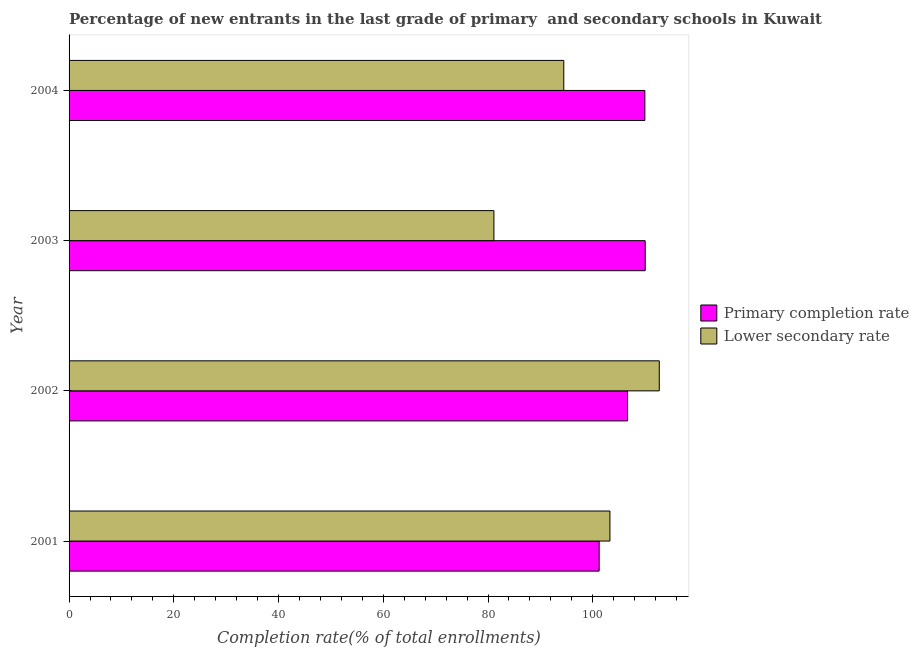How many different coloured bars are there?
Your answer should be very brief. 2. How many groups of bars are there?
Make the answer very short. 4. Are the number of bars on each tick of the Y-axis equal?
Your answer should be compact. Yes. How many bars are there on the 4th tick from the top?
Provide a short and direct response. 2. How many bars are there on the 4th tick from the bottom?
Provide a succinct answer. 2. What is the label of the 3rd group of bars from the top?
Ensure brevity in your answer.  2002. In how many cases, is the number of bars for a given year not equal to the number of legend labels?
Provide a succinct answer. 0. What is the completion rate in secondary schools in 2003?
Keep it short and to the point. 81.13. Across all years, what is the maximum completion rate in primary schools?
Make the answer very short. 110.02. Across all years, what is the minimum completion rate in primary schools?
Keep it short and to the point. 101.23. In which year was the completion rate in primary schools maximum?
Offer a very short reply. 2003. In which year was the completion rate in primary schools minimum?
Your response must be concise. 2001. What is the total completion rate in secondary schools in the graph?
Your answer should be very brief. 391.6. What is the difference between the completion rate in primary schools in 2003 and that in 2004?
Your answer should be compact. 0.06. What is the difference between the completion rate in primary schools in 2004 and the completion rate in secondary schools in 2001?
Provide a short and direct response. 6.67. What is the average completion rate in primary schools per year?
Your answer should be very brief. 106.96. In the year 2004, what is the difference between the completion rate in secondary schools and completion rate in primary schools?
Ensure brevity in your answer.  -15.48. What is the ratio of the completion rate in primary schools in 2001 to that in 2002?
Your response must be concise. 0.95. Is the completion rate in primary schools in 2001 less than that in 2003?
Offer a terse response. Yes. Is the difference between the completion rate in secondary schools in 2002 and 2003 greater than the difference between the completion rate in primary schools in 2002 and 2003?
Your answer should be very brief. Yes. What is the difference between the highest and the second highest completion rate in secondary schools?
Make the answer very short. 9.42. What is the difference between the highest and the lowest completion rate in secondary schools?
Keep it short and to the point. 31.58. Is the sum of the completion rate in secondary schools in 2001 and 2004 greater than the maximum completion rate in primary schools across all years?
Ensure brevity in your answer.  Yes. What does the 2nd bar from the top in 2001 represents?
Your answer should be compact. Primary completion rate. What does the 1st bar from the bottom in 2001 represents?
Give a very brief answer. Primary completion rate. Are all the bars in the graph horizontal?
Make the answer very short. Yes. What is the difference between two consecutive major ticks on the X-axis?
Provide a short and direct response. 20. Are the values on the major ticks of X-axis written in scientific E-notation?
Make the answer very short. No. Does the graph contain grids?
Your answer should be compact. No. Where does the legend appear in the graph?
Keep it short and to the point. Center right. How are the legend labels stacked?
Offer a terse response. Vertical. What is the title of the graph?
Your answer should be compact. Percentage of new entrants in the last grade of primary  and secondary schools in Kuwait. Does "International Visitors" appear as one of the legend labels in the graph?
Your answer should be very brief. No. What is the label or title of the X-axis?
Provide a succinct answer. Completion rate(% of total enrollments). What is the Completion rate(% of total enrollments) in Primary completion rate in 2001?
Your answer should be compact. 101.23. What is the Completion rate(% of total enrollments) in Lower secondary rate in 2001?
Provide a succinct answer. 103.29. What is the Completion rate(% of total enrollments) in Primary completion rate in 2002?
Your answer should be compact. 106.65. What is the Completion rate(% of total enrollments) in Lower secondary rate in 2002?
Give a very brief answer. 112.71. What is the Completion rate(% of total enrollments) in Primary completion rate in 2003?
Offer a very short reply. 110.02. What is the Completion rate(% of total enrollments) of Lower secondary rate in 2003?
Keep it short and to the point. 81.13. What is the Completion rate(% of total enrollments) in Primary completion rate in 2004?
Keep it short and to the point. 109.96. What is the Completion rate(% of total enrollments) of Lower secondary rate in 2004?
Provide a short and direct response. 94.47. Across all years, what is the maximum Completion rate(% of total enrollments) of Primary completion rate?
Your answer should be compact. 110.02. Across all years, what is the maximum Completion rate(% of total enrollments) in Lower secondary rate?
Your answer should be very brief. 112.71. Across all years, what is the minimum Completion rate(% of total enrollments) of Primary completion rate?
Your response must be concise. 101.23. Across all years, what is the minimum Completion rate(% of total enrollments) in Lower secondary rate?
Your answer should be compact. 81.13. What is the total Completion rate(% of total enrollments) of Primary completion rate in the graph?
Give a very brief answer. 427.86. What is the total Completion rate(% of total enrollments) in Lower secondary rate in the graph?
Make the answer very short. 391.6. What is the difference between the Completion rate(% of total enrollments) in Primary completion rate in 2001 and that in 2002?
Keep it short and to the point. -5.42. What is the difference between the Completion rate(% of total enrollments) of Lower secondary rate in 2001 and that in 2002?
Ensure brevity in your answer.  -9.42. What is the difference between the Completion rate(% of total enrollments) of Primary completion rate in 2001 and that in 2003?
Offer a very short reply. -8.79. What is the difference between the Completion rate(% of total enrollments) of Lower secondary rate in 2001 and that in 2003?
Make the answer very short. 22.16. What is the difference between the Completion rate(% of total enrollments) in Primary completion rate in 2001 and that in 2004?
Offer a terse response. -8.73. What is the difference between the Completion rate(% of total enrollments) in Lower secondary rate in 2001 and that in 2004?
Give a very brief answer. 8.81. What is the difference between the Completion rate(% of total enrollments) of Primary completion rate in 2002 and that in 2003?
Your answer should be very brief. -3.37. What is the difference between the Completion rate(% of total enrollments) in Lower secondary rate in 2002 and that in 2003?
Make the answer very short. 31.58. What is the difference between the Completion rate(% of total enrollments) of Primary completion rate in 2002 and that in 2004?
Offer a very short reply. -3.3. What is the difference between the Completion rate(% of total enrollments) of Lower secondary rate in 2002 and that in 2004?
Provide a short and direct response. 18.24. What is the difference between the Completion rate(% of total enrollments) of Primary completion rate in 2003 and that in 2004?
Make the answer very short. 0.06. What is the difference between the Completion rate(% of total enrollments) in Lower secondary rate in 2003 and that in 2004?
Your response must be concise. -13.34. What is the difference between the Completion rate(% of total enrollments) in Primary completion rate in 2001 and the Completion rate(% of total enrollments) in Lower secondary rate in 2002?
Provide a short and direct response. -11.48. What is the difference between the Completion rate(% of total enrollments) in Primary completion rate in 2001 and the Completion rate(% of total enrollments) in Lower secondary rate in 2003?
Provide a succinct answer. 20.1. What is the difference between the Completion rate(% of total enrollments) of Primary completion rate in 2001 and the Completion rate(% of total enrollments) of Lower secondary rate in 2004?
Offer a very short reply. 6.75. What is the difference between the Completion rate(% of total enrollments) of Primary completion rate in 2002 and the Completion rate(% of total enrollments) of Lower secondary rate in 2003?
Give a very brief answer. 25.52. What is the difference between the Completion rate(% of total enrollments) of Primary completion rate in 2002 and the Completion rate(% of total enrollments) of Lower secondary rate in 2004?
Offer a terse response. 12.18. What is the difference between the Completion rate(% of total enrollments) of Primary completion rate in 2003 and the Completion rate(% of total enrollments) of Lower secondary rate in 2004?
Provide a short and direct response. 15.55. What is the average Completion rate(% of total enrollments) of Primary completion rate per year?
Offer a terse response. 106.96. What is the average Completion rate(% of total enrollments) of Lower secondary rate per year?
Ensure brevity in your answer.  97.9. In the year 2001, what is the difference between the Completion rate(% of total enrollments) of Primary completion rate and Completion rate(% of total enrollments) of Lower secondary rate?
Your response must be concise. -2.06. In the year 2002, what is the difference between the Completion rate(% of total enrollments) in Primary completion rate and Completion rate(% of total enrollments) in Lower secondary rate?
Offer a terse response. -6.06. In the year 2003, what is the difference between the Completion rate(% of total enrollments) in Primary completion rate and Completion rate(% of total enrollments) in Lower secondary rate?
Keep it short and to the point. 28.89. In the year 2004, what is the difference between the Completion rate(% of total enrollments) in Primary completion rate and Completion rate(% of total enrollments) in Lower secondary rate?
Keep it short and to the point. 15.48. What is the ratio of the Completion rate(% of total enrollments) in Primary completion rate in 2001 to that in 2002?
Ensure brevity in your answer.  0.95. What is the ratio of the Completion rate(% of total enrollments) of Lower secondary rate in 2001 to that in 2002?
Give a very brief answer. 0.92. What is the ratio of the Completion rate(% of total enrollments) of Primary completion rate in 2001 to that in 2003?
Offer a very short reply. 0.92. What is the ratio of the Completion rate(% of total enrollments) of Lower secondary rate in 2001 to that in 2003?
Your response must be concise. 1.27. What is the ratio of the Completion rate(% of total enrollments) in Primary completion rate in 2001 to that in 2004?
Keep it short and to the point. 0.92. What is the ratio of the Completion rate(% of total enrollments) of Lower secondary rate in 2001 to that in 2004?
Make the answer very short. 1.09. What is the ratio of the Completion rate(% of total enrollments) in Primary completion rate in 2002 to that in 2003?
Provide a short and direct response. 0.97. What is the ratio of the Completion rate(% of total enrollments) of Lower secondary rate in 2002 to that in 2003?
Give a very brief answer. 1.39. What is the ratio of the Completion rate(% of total enrollments) in Primary completion rate in 2002 to that in 2004?
Offer a terse response. 0.97. What is the ratio of the Completion rate(% of total enrollments) of Lower secondary rate in 2002 to that in 2004?
Your answer should be compact. 1.19. What is the ratio of the Completion rate(% of total enrollments) in Lower secondary rate in 2003 to that in 2004?
Provide a succinct answer. 0.86. What is the difference between the highest and the second highest Completion rate(% of total enrollments) of Primary completion rate?
Keep it short and to the point. 0.06. What is the difference between the highest and the second highest Completion rate(% of total enrollments) of Lower secondary rate?
Offer a terse response. 9.42. What is the difference between the highest and the lowest Completion rate(% of total enrollments) in Primary completion rate?
Offer a terse response. 8.79. What is the difference between the highest and the lowest Completion rate(% of total enrollments) in Lower secondary rate?
Your answer should be compact. 31.58. 